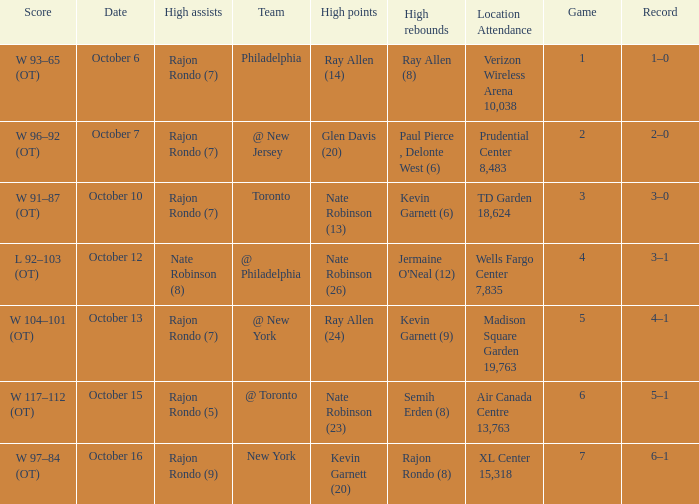Who had the most assists and how many did they have on October 7?  Rajon Rondo (7). 